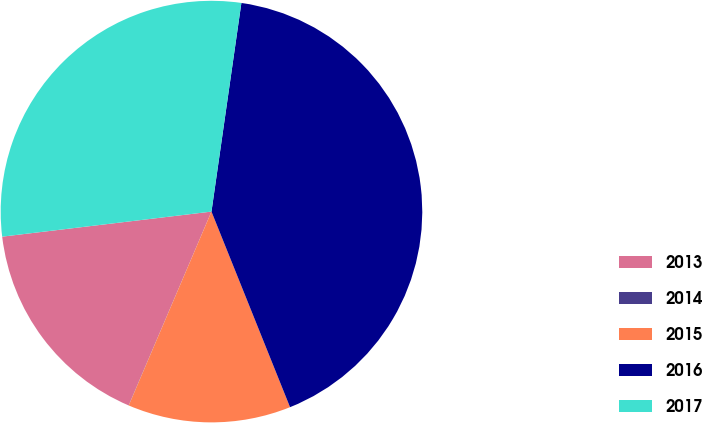Convert chart. <chart><loc_0><loc_0><loc_500><loc_500><pie_chart><fcel>2013<fcel>2014<fcel>2015<fcel>2016<fcel>2017<nl><fcel>16.67%<fcel>0.01%<fcel>12.5%<fcel>41.65%<fcel>29.16%<nl></chart> 